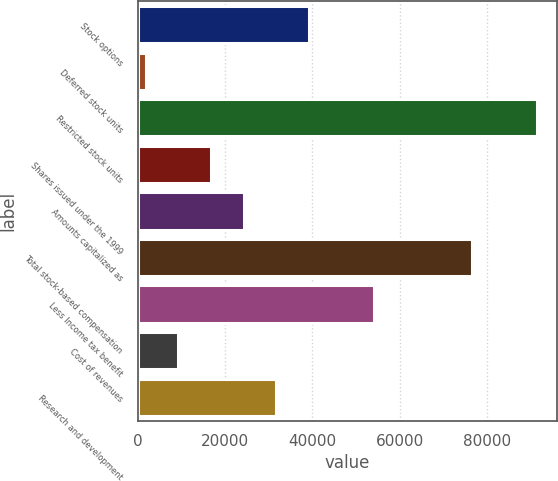Convert chart to OTSL. <chart><loc_0><loc_0><loc_500><loc_500><bar_chart><fcel>Stock options<fcel>Deferred stock units<fcel>Restricted stock units<fcel>Shares issued under the 1999<fcel>Amounts capitalized as<fcel>Total stock-based compensation<fcel>Less Income tax benefit<fcel>Cost of revenues<fcel>Research and development<nl><fcel>39176.5<fcel>1885<fcel>91384.6<fcel>16801.6<fcel>24259.9<fcel>76468<fcel>54093.1<fcel>9343.3<fcel>31718.2<nl></chart> 